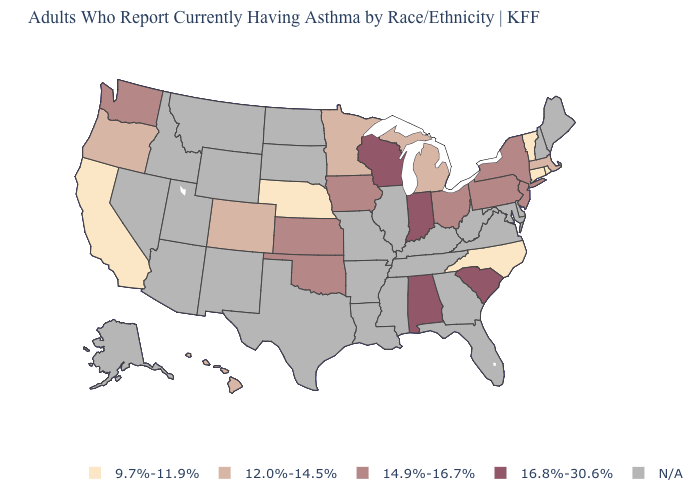How many symbols are there in the legend?
Write a very short answer. 5. Among the states that border Indiana , which have the lowest value?
Be succinct. Michigan. What is the value of Connecticut?
Keep it brief. 9.7%-11.9%. Does the first symbol in the legend represent the smallest category?
Concise answer only. Yes. Does the map have missing data?
Concise answer only. Yes. Does Rhode Island have the lowest value in the Northeast?
Write a very short answer. Yes. How many symbols are there in the legend?
Be succinct. 5. What is the highest value in the MidWest ?
Answer briefly. 16.8%-30.6%. Name the states that have a value in the range 9.7%-11.9%?
Give a very brief answer. California, Connecticut, Nebraska, North Carolina, Rhode Island, Vermont. How many symbols are there in the legend?
Short answer required. 5. What is the value of Utah?
Concise answer only. N/A. Name the states that have a value in the range 14.9%-16.7%?
Answer briefly. Iowa, Kansas, New Jersey, New York, Ohio, Oklahoma, Pennsylvania, Washington. What is the lowest value in states that border Pennsylvania?
Keep it brief. 14.9%-16.7%. Which states hav the highest value in the Northeast?
Quick response, please. New Jersey, New York, Pennsylvania. 